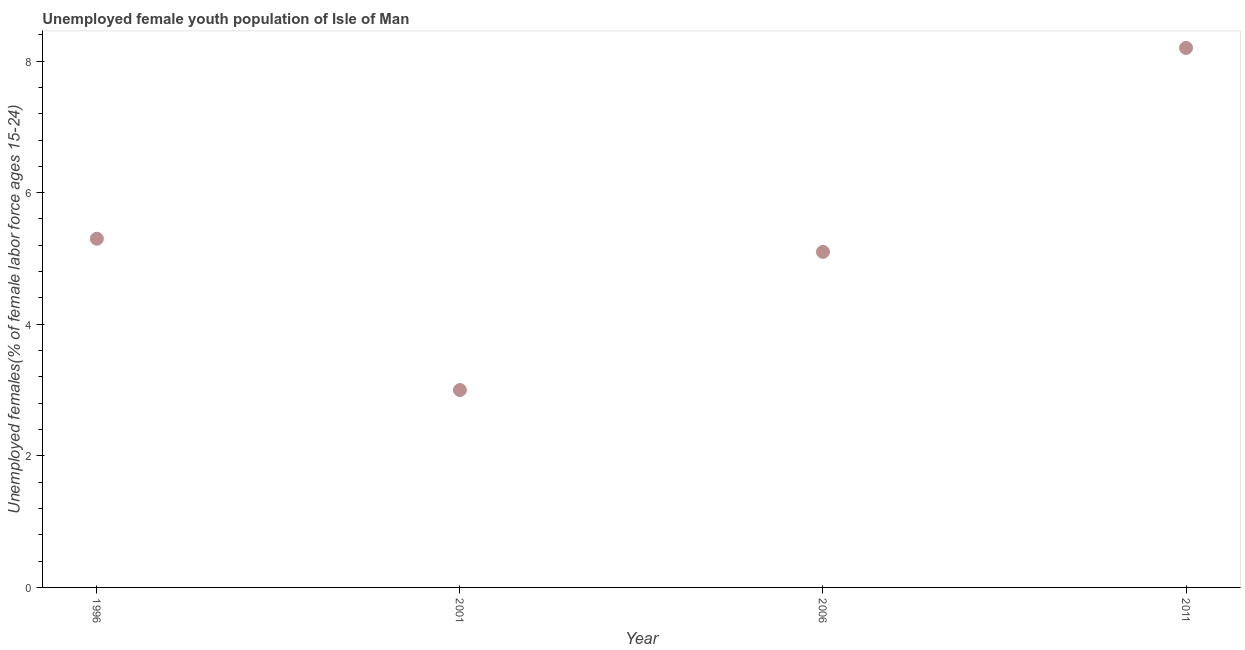What is the unemployed female youth in 2011?
Provide a succinct answer. 8.2. Across all years, what is the maximum unemployed female youth?
Your answer should be compact. 8.2. Across all years, what is the minimum unemployed female youth?
Ensure brevity in your answer.  3. In which year was the unemployed female youth minimum?
Your response must be concise. 2001. What is the sum of the unemployed female youth?
Keep it short and to the point. 21.6. What is the difference between the unemployed female youth in 2001 and 2011?
Provide a succinct answer. -5.2. What is the average unemployed female youth per year?
Provide a succinct answer. 5.4. What is the median unemployed female youth?
Ensure brevity in your answer.  5.2. In how many years, is the unemployed female youth greater than 8 %?
Your answer should be very brief. 1. Do a majority of the years between 2006 and 2011 (inclusive) have unemployed female youth greater than 0.4 %?
Give a very brief answer. Yes. What is the ratio of the unemployed female youth in 2006 to that in 2011?
Your answer should be compact. 0.62. Is the unemployed female youth in 1996 less than that in 2001?
Ensure brevity in your answer.  No. What is the difference between the highest and the second highest unemployed female youth?
Give a very brief answer. 2.9. What is the difference between the highest and the lowest unemployed female youth?
Keep it short and to the point. 5.2. In how many years, is the unemployed female youth greater than the average unemployed female youth taken over all years?
Offer a terse response. 1. How many dotlines are there?
Your answer should be very brief. 1. How many years are there in the graph?
Your response must be concise. 4. What is the title of the graph?
Keep it short and to the point. Unemployed female youth population of Isle of Man. What is the label or title of the Y-axis?
Offer a terse response. Unemployed females(% of female labor force ages 15-24). What is the Unemployed females(% of female labor force ages 15-24) in 1996?
Your answer should be compact. 5.3. What is the Unemployed females(% of female labor force ages 15-24) in 2006?
Ensure brevity in your answer.  5.1. What is the Unemployed females(% of female labor force ages 15-24) in 2011?
Keep it short and to the point. 8.2. What is the difference between the Unemployed females(% of female labor force ages 15-24) in 1996 and 2011?
Ensure brevity in your answer.  -2.9. What is the difference between the Unemployed females(% of female labor force ages 15-24) in 2006 and 2011?
Provide a short and direct response. -3.1. What is the ratio of the Unemployed females(% of female labor force ages 15-24) in 1996 to that in 2001?
Ensure brevity in your answer.  1.77. What is the ratio of the Unemployed females(% of female labor force ages 15-24) in 1996 to that in 2006?
Your answer should be very brief. 1.04. What is the ratio of the Unemployed females(% of female labor force ages 15-24) in 1996 to that in 2011?
Ensure brevity in your answer.  0.65. What is the ratio of the Unemployed females(% of female labor force ages 15-24) in 2001 to that in 2006?
Provide a short and direct response. 0.59. What is the ratio of the Unemployed females(% of female labor force ages 15-24) in 2001 to that in 2011?
Provide a succinct answer. 0.37. What is the ratio of the Unemployed females(% of female labor force ages 15-24) in 2006 to that in 2011?
Your response must be concise. 0.62. 